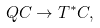Convert formula to latex. <formula><loc_0><loc_0><loc_500><loc_500>Q C \to T ^ { * } C ,</formula> 